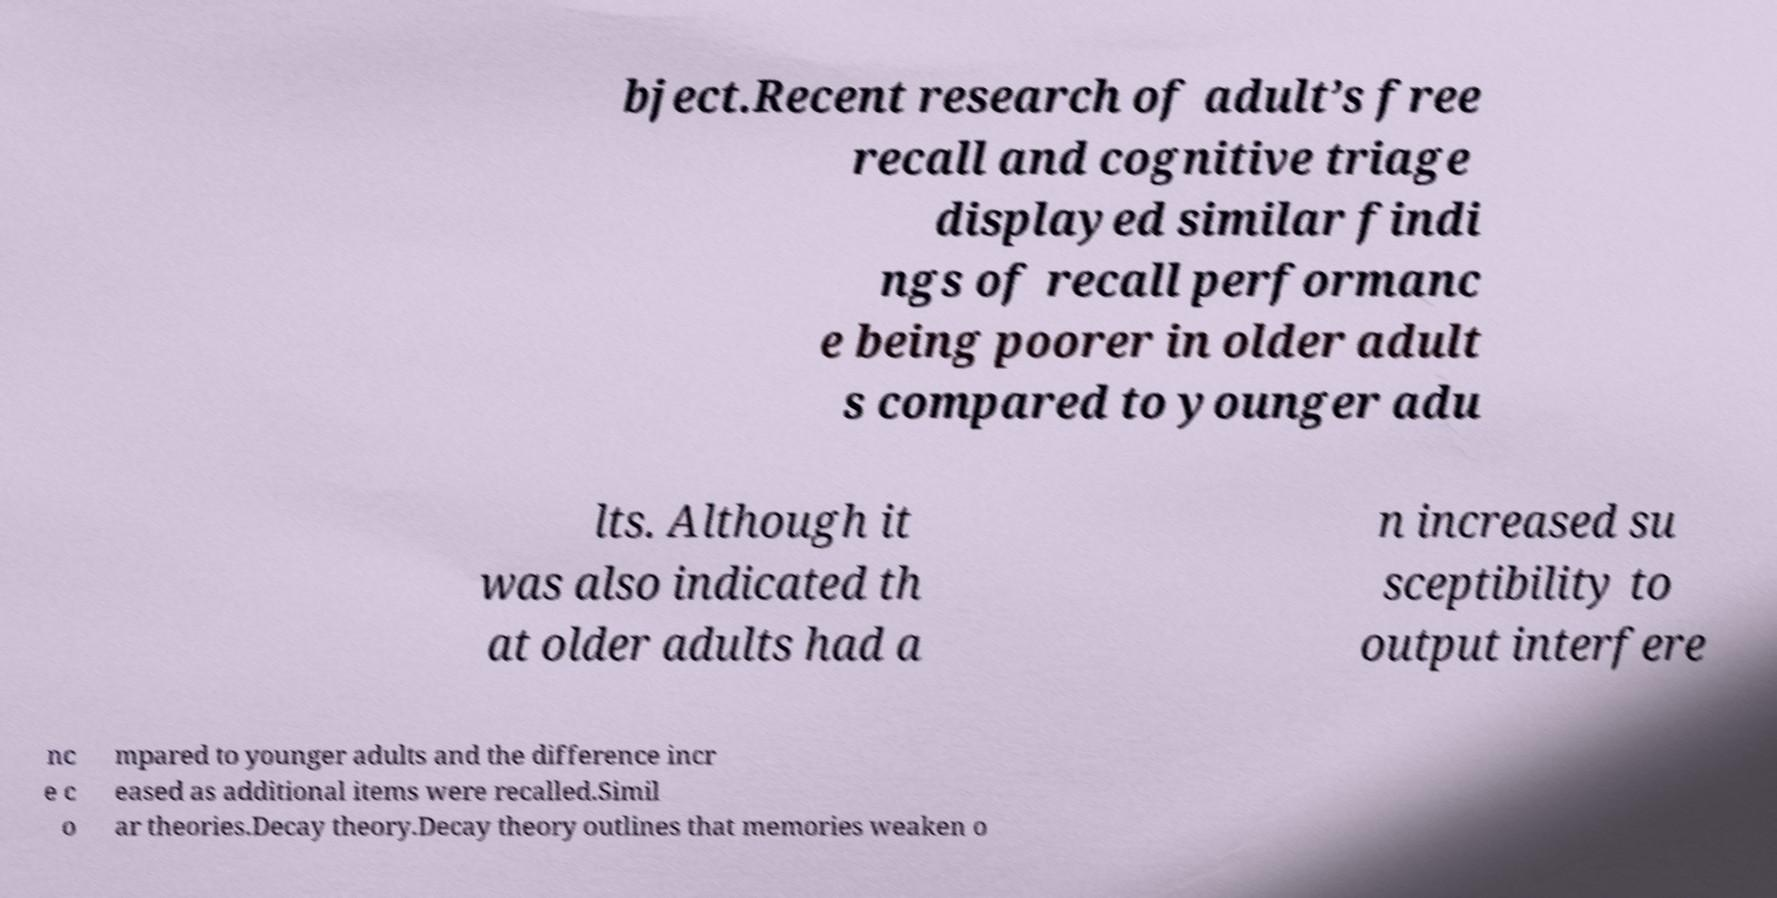Could you extract and type out the text from this image? bject.Recent research of adult’s free recall and cognitive triage displayed similar findi ngs of recall performanc e being poorer in older adult s compared to younger adu lts. Although it was also indicated th at older adults had a n increased su sceptibility to output interfere nc e c o mpared to younger adults and the difference incr eased as additional items were recalled.Simil ar theories.Decay theory.Decay theory outlines that memories weaken o 